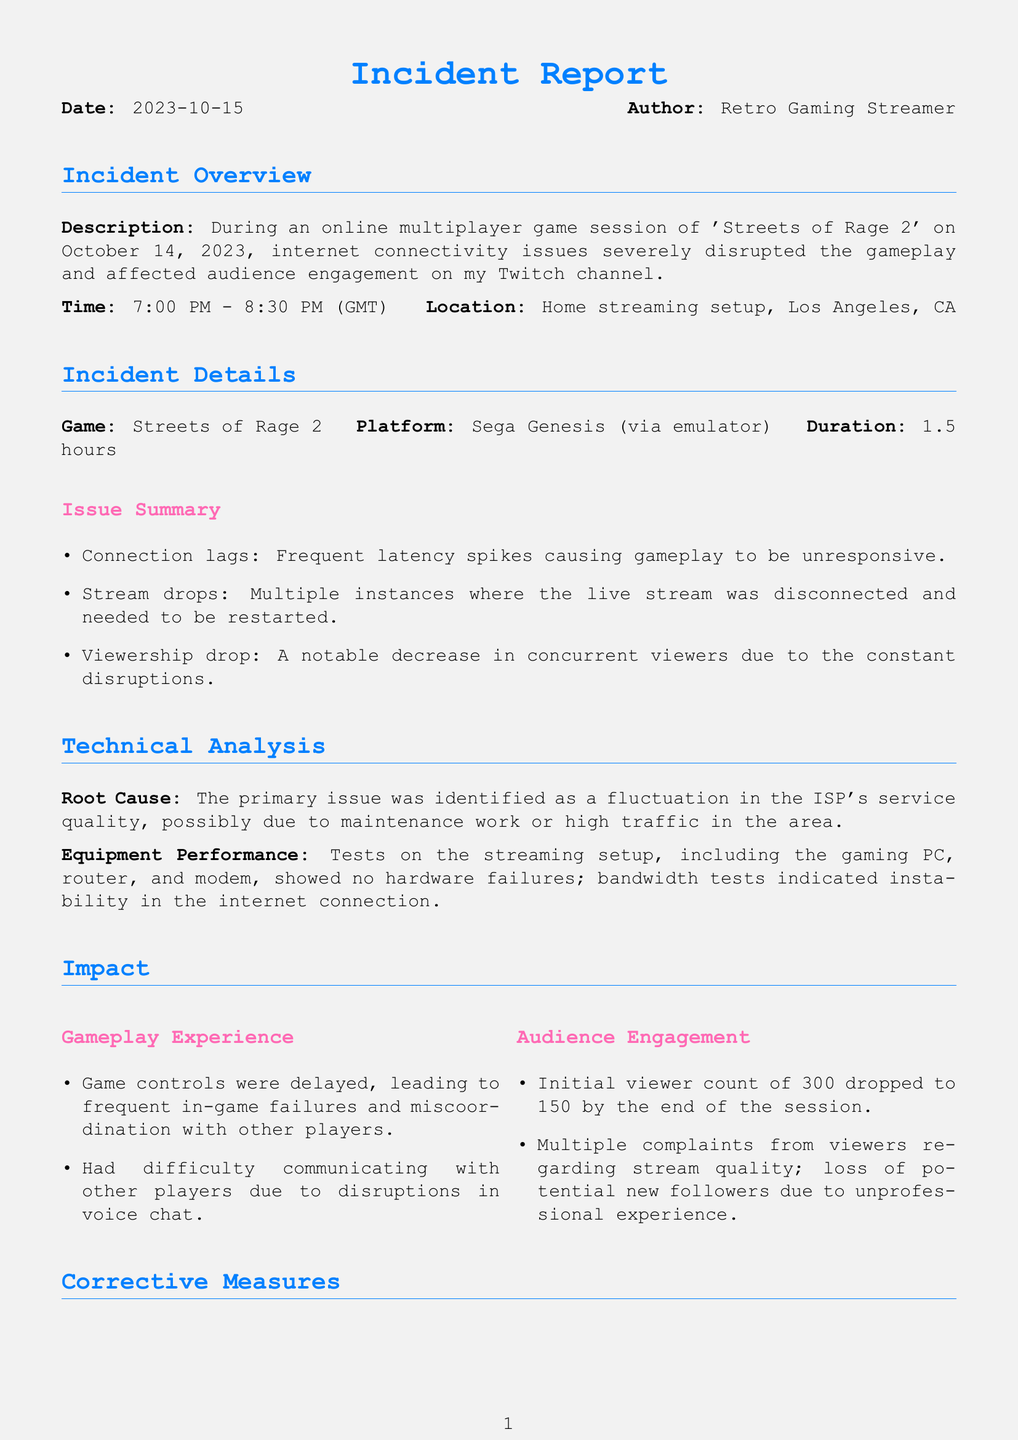What was the date of the incident? The date of the incident is mentioned in the report.
Answer: 2023-10-14 What game was being streamed? The report specifies which game was played during the session.
Answer: Streets of Rage 2 What was the initial viewer count? The initial viewer count is provided in the audience engagement section.
Answer: 300 What was the duration of the game session? The report states the time length of the game session clearly.
Answer: 1.5 hours What were the immediate corrective measures taken? The report outlines the first actions taken to resolve the issue.
Answer: Restarted the router What was the conclusion about the cause of the issues? The report summarizes the main cause identified for the problems encountered.
Answer: Fluctuations in ISP service quality How many concurrent viewers were there at the end of the session? The report details the viewer count at the end of the session.
Answer: 150 What type of connection was used for streaming? The report specifies the setup used during the streaming session.
Answer: Emulator What were the viewer complaints related to? The audience engagement section highlights what viewers complained about during the stream.
Answer: Stream quality What is the long-term plan regarding internet service? The report mentions the future actions planned concerning the internet service.
Answer: Reach out to the ISP 